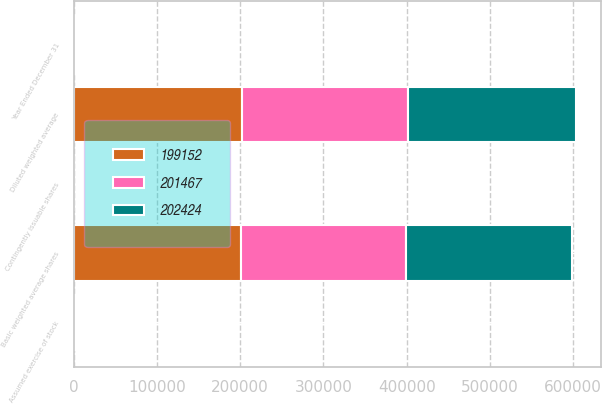<chart> <loc_0><loc_0><loc_500><loc_500><stacked_bar_chart><ecel><fcel>Year Ended December 31<fcel>Basic weighted average shares<fcel>Assumed exercise of stock<fcel>Contingently issuable shares<fcel>Diluted weighted average<nl><fcel>199152<fcel>2005<fcel>200819<fcel>1555<fcel>50<fcel>202424<nl><fcel>202424<fcel>2004<fcel>199563<fcel>1702<fcel>202<fcel>201467<nl><fcel>201467<fcel>2003<fcel>197790<fcel>1237<fcel>125<fcel>199152<nl></chart> 